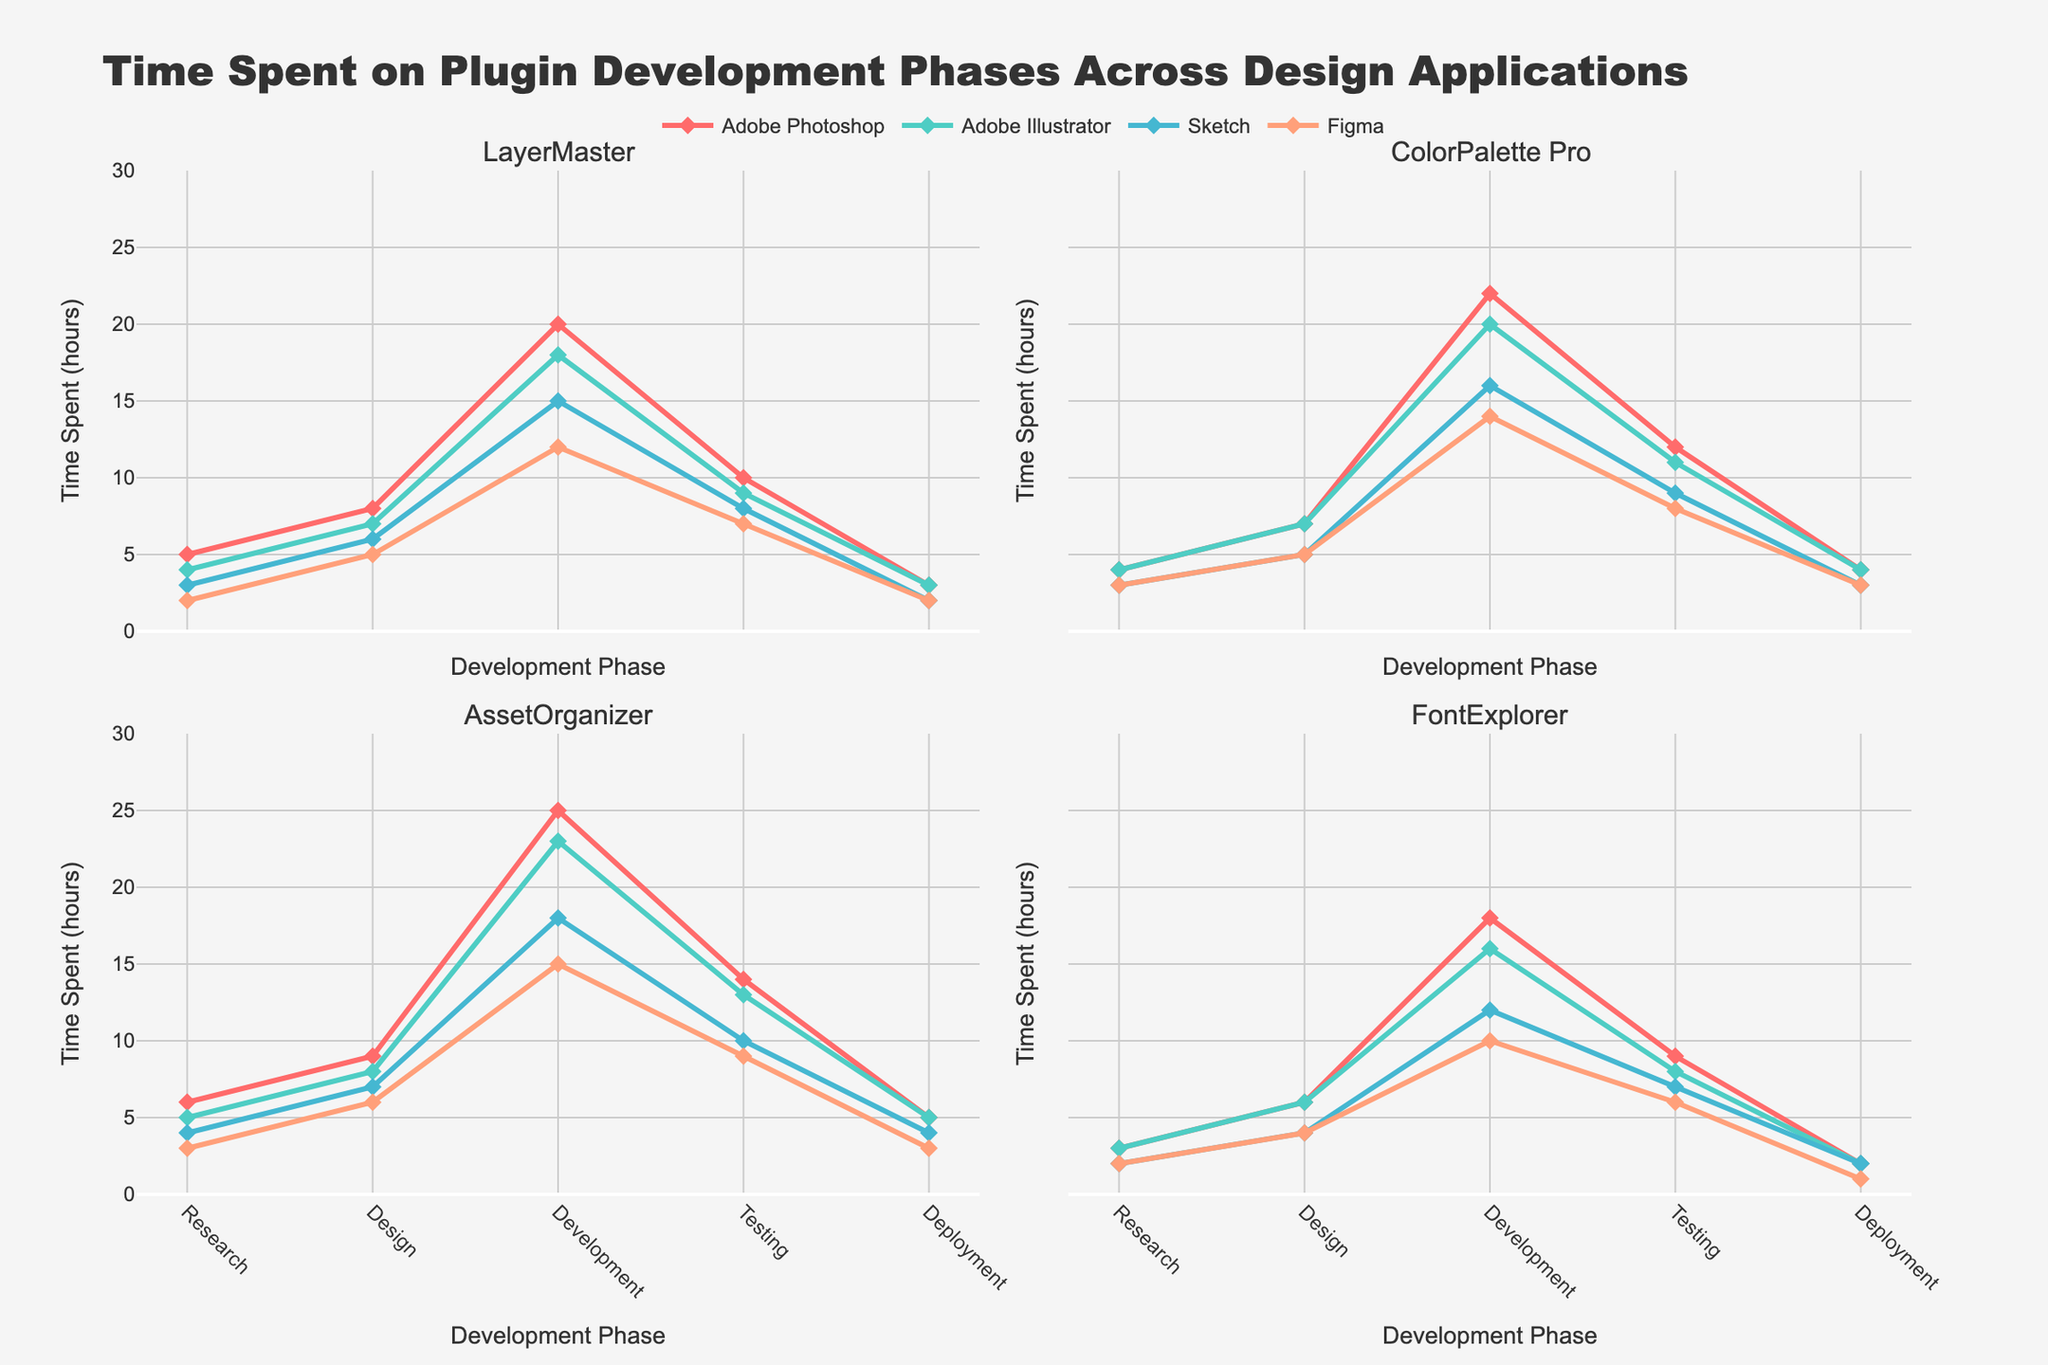What is the total time spent on the development phase for the 'ColorPalette Pro' project in Adobe Photoshop? Summing the time spent on the development phase for the 'ColorPalette Pro' project as shown in the Adobe Photoshop line chart data, it's 22 hours.
Answer: 22 hours In which design application and project does the research phase consume the least time? Comparing the research phase times across all design applications and projects: 'FontExplorer' in Adobe Photoshop takes 3 hours, which is the lowest 'Research' phase time.
Answer: FontExplorer in Adobe Photoshop How does the development time for 'LayerMaster' in 'Figma' compare to 'AssetOrganizer' in 'Sketch'? From the subplot, 'LayerMaster' in Figma has 12 hours of development time, and 'AssetOrganizer' in Sketch has 18 hours of development time. Comparing these, 12 hours is less than 18 hours.
Answer: Less What is the average testing time across all phases for the 'Adobe Illustrator' application? Summing all testing times for 'Adobe Illustrator': 9 (LayerMaster) + 11 (ColorPalette Pro) + 13 (AssetOrganizer) + 8 (FontExplorer) = 41, divided by 4 gives an average of 10.25 hours.
Answer: 10.25 hours Which project has the shortest deployment phase in the 'Sketch' application? By inspecting the deployment phase times in the 'Sketch' application, 'FontExplorer' has the least time with 2 hours in the deployment phase.
Answer: FontExplorer Which phase shows the maximum time spent in 'Figma' for the 'AssetOrganizer' project? Checking 'AssetOrganizer' in 'Figma', the development phase shows the maximum time spent with 15 hours.
Answer: Development How much more time is spent on development in 'Adobe Illustrator' for 'LayerMaster' compared to 'FontExplorer'? Subtracting the development time for 'FontExplorer' (16 hours) from 'LayerMaster' (18 hours) in 'Adobe Illustrator', it shows 18 - 16 = 2 hours difference.
Answer: 2 hours For the 'ColorPalette Pro' project, what is the difference in time spent between research and deployment phases across all applications? Adding research phase times: 4 (Adobe Photoshop) + 4 (Adobe Illustrator) + 3 (Sketch) + 3 (Figma) = 14 hours, and deployment phase times: 4 (Adobe Photoshop) + 4 (Adobe Illustrator) + 3 (Sketch) + 3 (Figma) = 14 hours. The difference is 14 - 14 = 0 hours.
Answer: 0 hours What is the sum of time spent on testing phases by 'Sketch' for 'LayerMaster' and 'ColorPalette Pro'? Summing the testing phase times for 'LayerMaster' (8) and 'ColorPalette Pro' (9) in 'Sketch' equals 8 + 9 = 17 hours.
Answer: 17 hours 